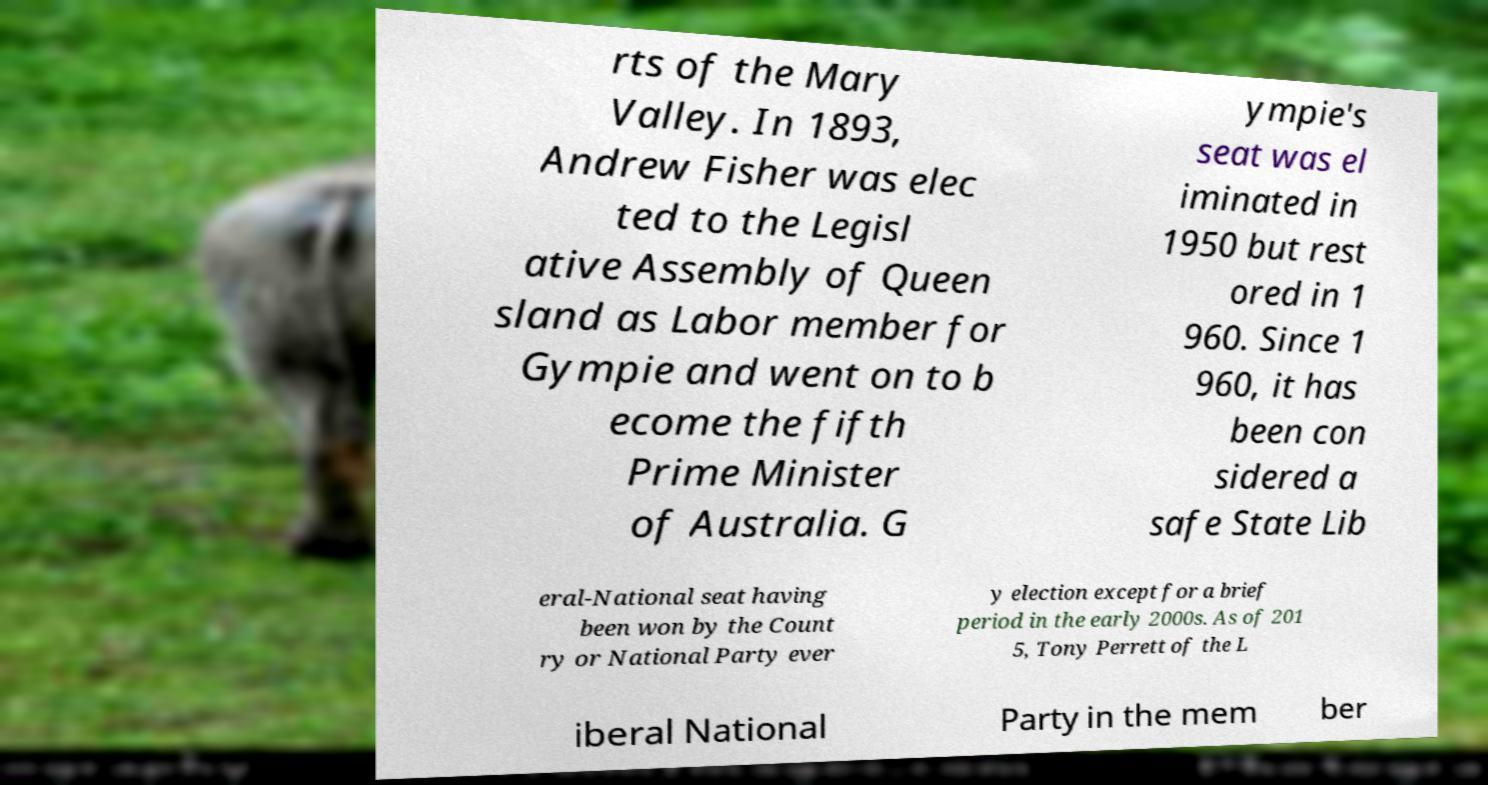There's text embedded in this image that I need extracted. Can you transcribe it verbatim? rts of the Mary Valley. In 1893, Andrew Fisher was elec ted to the Legisl ative Assembly of Queen sland as Labor member for Gympie and went on to b ecome the fifth Prime Minister of Australia. G ympie's seat was el iminated in 1950 but rest ored in 1 960. Since 1 960, it has been con sidered a safe State Lib eral-National seat having been won by the Count ry or National Party ever y election except for a brief period in the early 2000s. As of 201 5, Tony Perrett of the L iberal National Party in the mem ber 